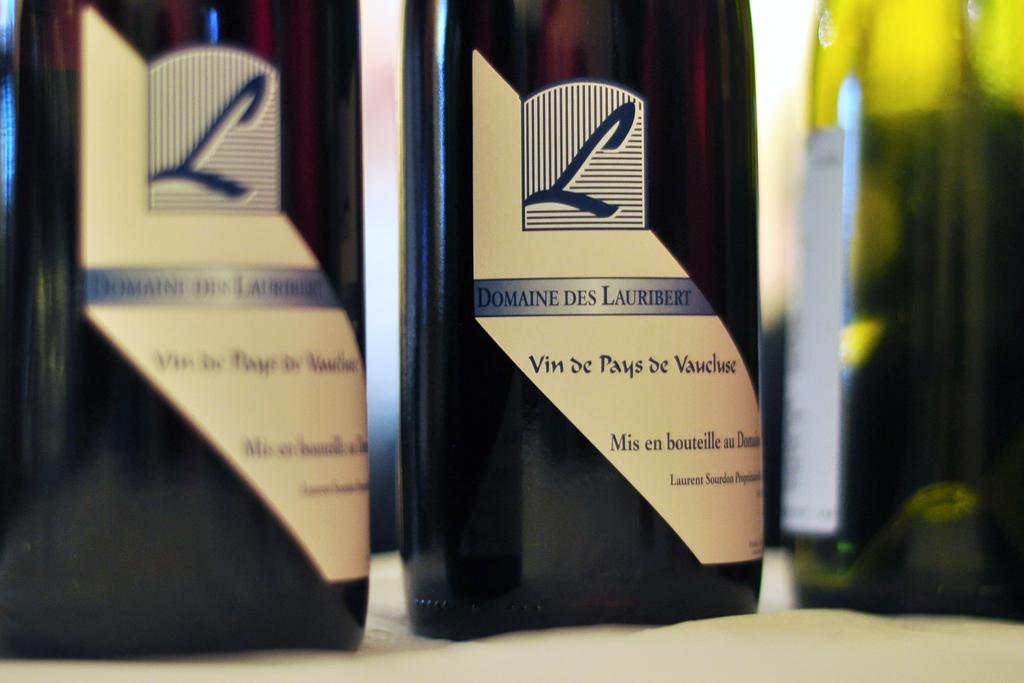What letter is at the top of the label on the bottle?
Provide a short and direct response. L. Who makes this wine?
Make the answer very short. Domaine des lauribert. 